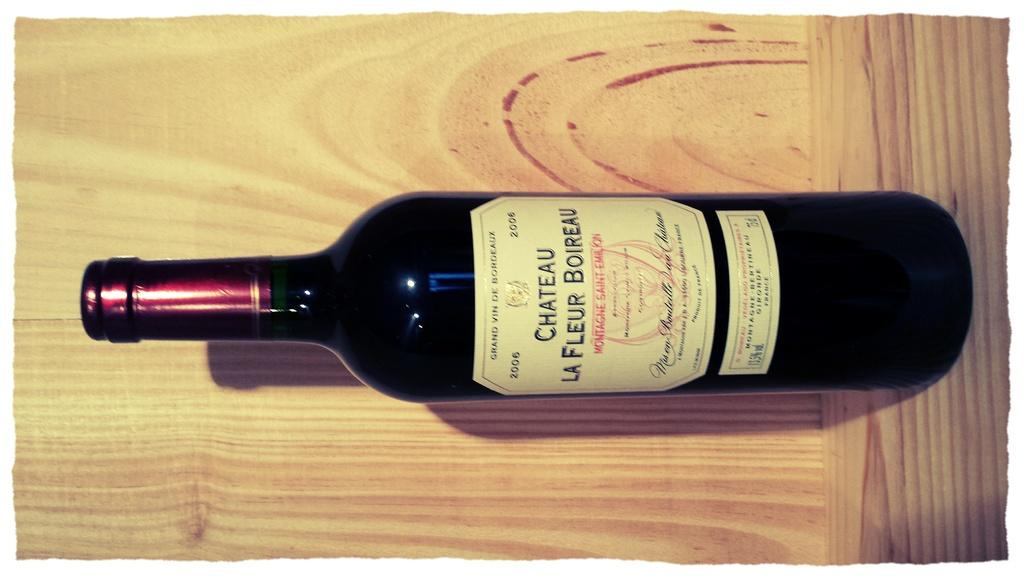<image>
Create a compact narrative representing the image presented. A bottle of red wine on its side and Chateu La fleur on the label 